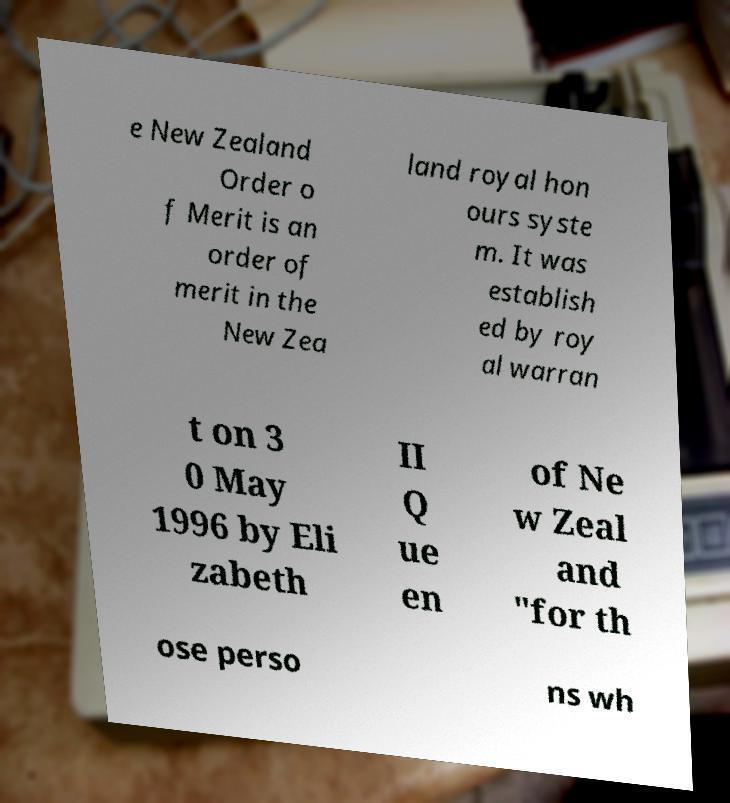Can you read and provide the text displayed in the image?This photo seems to have some interesting text. Can you extract and type it out for me? e New Zealand Order o f Merit is an order of merit in the New Zea land royal hon ours syste m. It was establish ed by roy al warran t on 3 0 May 1996 by Eli zabeth II Q ue en of Ne w Zeal and "for th ose perso ns wh 